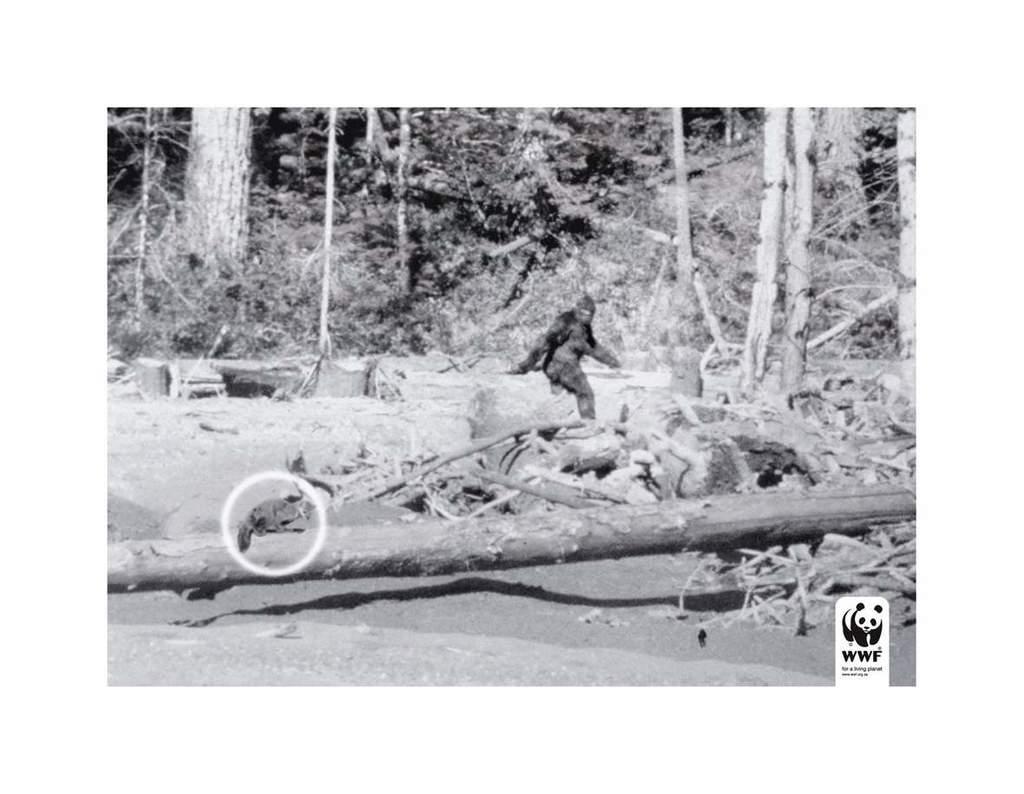Describe this image in one or two sentences. In this image I can see an animal on the wooden log. I can see there is a something which looks like an animal. There are few more wooden logs. In the back I can see many trees. 